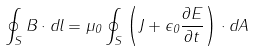Convert formula to latex. <formula><loc_0><loc_0><loc_500><loc_500>\oint _ { S } B \cdot { d } l = \mu _ { 0 } \oint _ { S } \left ( J + \epsilon _ { 0 } { \frac { \partial E } { \partial t } } \right ) \cdot { d } A \,</formula> 